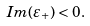<formula> <loc_0><loc_0><loc_500><loc_500>I m ( \varepsilon _ { + } ) < 0 .</formula> 